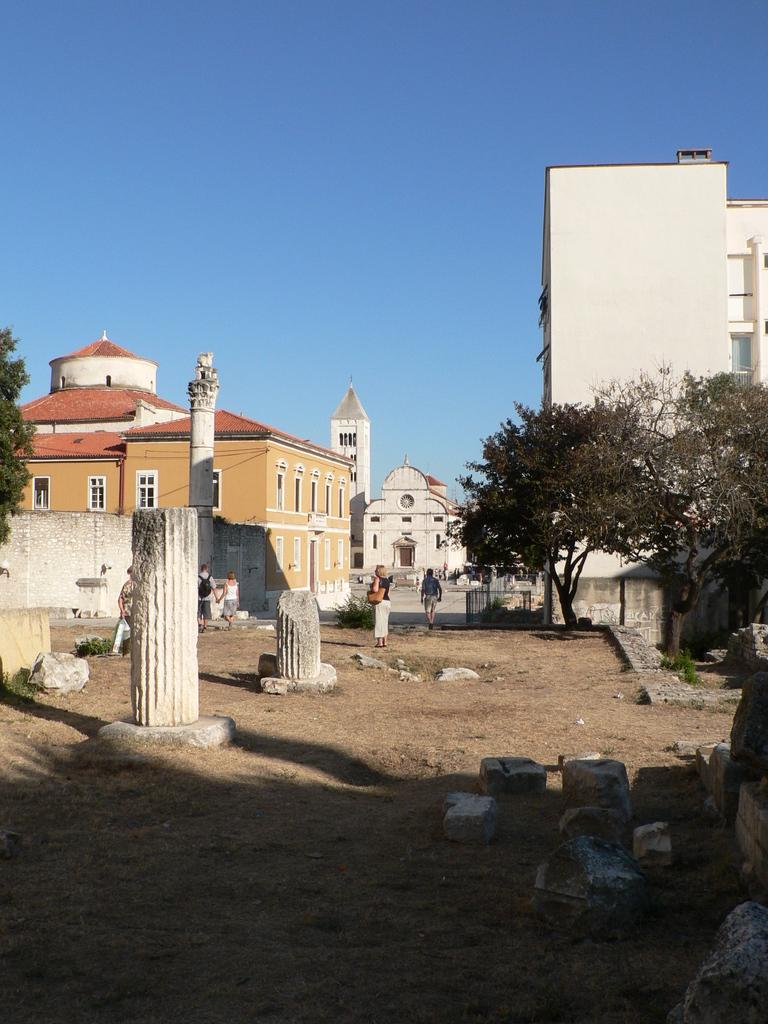What type of objects can be seen in the image? There are stones in the image. What can be seen in the background of the image? There are people, buildings, trees, and the sky visible in the background of the image. What type of kettle can be seen in the image? There is no kettle present in the image. What sound does the horn make in the image? There is no horn present in the image, so it is not possible to determine the sound it would make. 